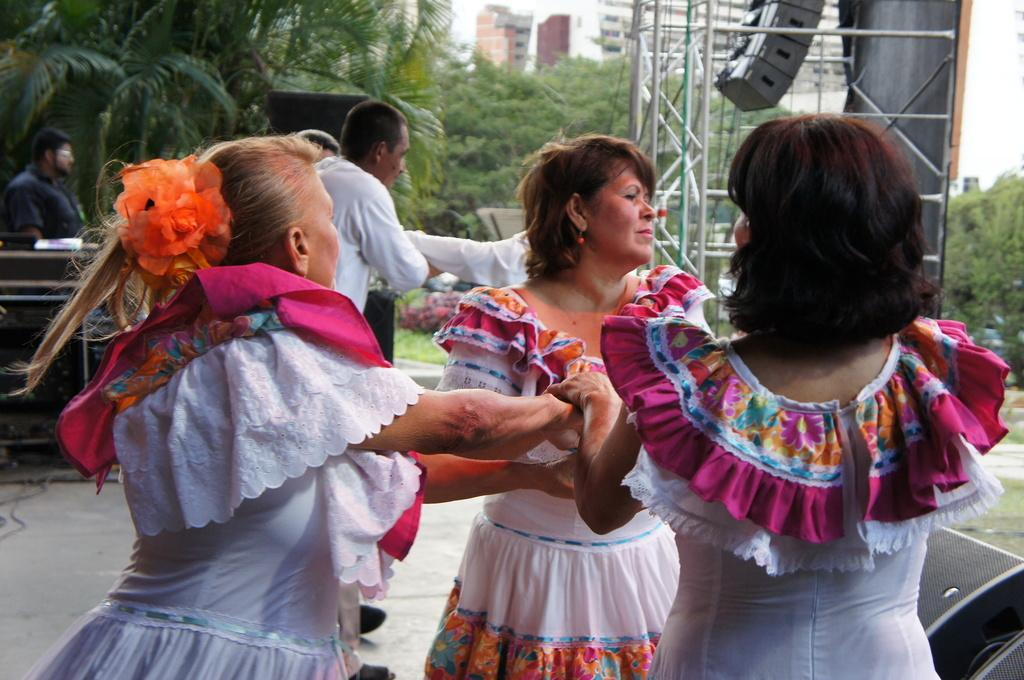How many women are in the foreground of the image? There are three women standing in the foreground. Can you describe the people in the background of the image? There are other people standing in the background. What type of natural environment is visible in the image? There are trees visible in the image. What committee is the school discussing in the image? There is no school or committee present in the image; it features three women and other people standing in the background. 